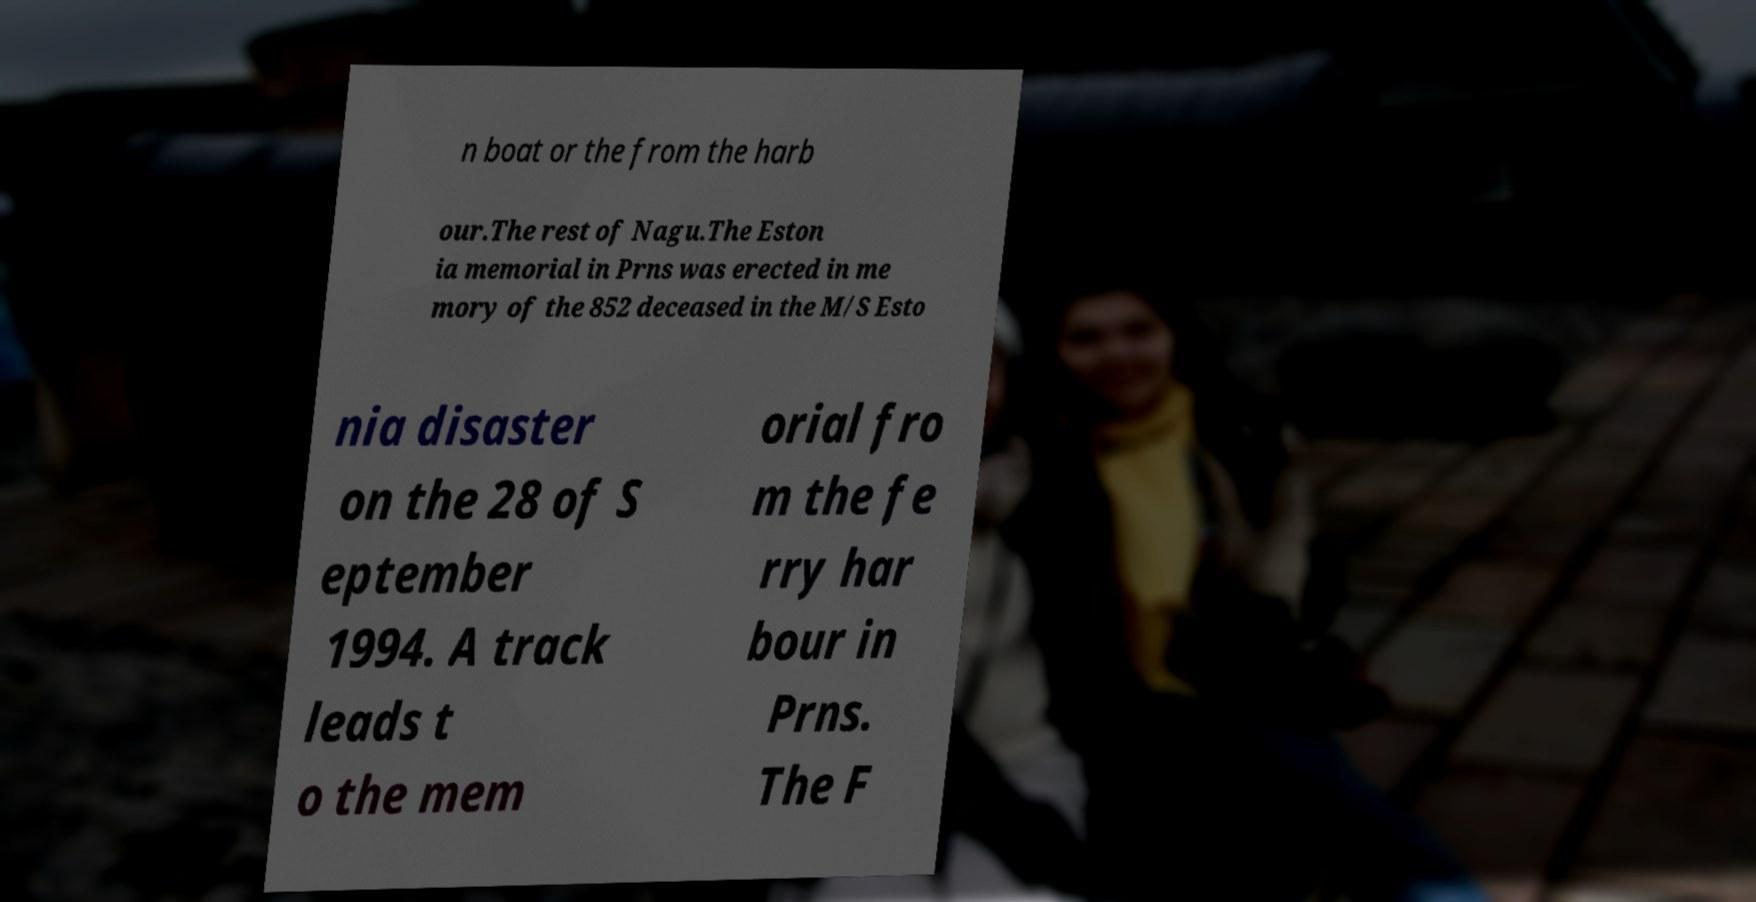Please identify and transcribe the text found in this image. n boat or the from the harb our.The rest of Nagu.The Eston ia memorial in Prns was erected in me mory of the 852 deceased in the M/S Esto nia disaster on the 28 of S eptember 1994. A track leads t o the mem orial fro m the fe rry har bour in Prns. The F 